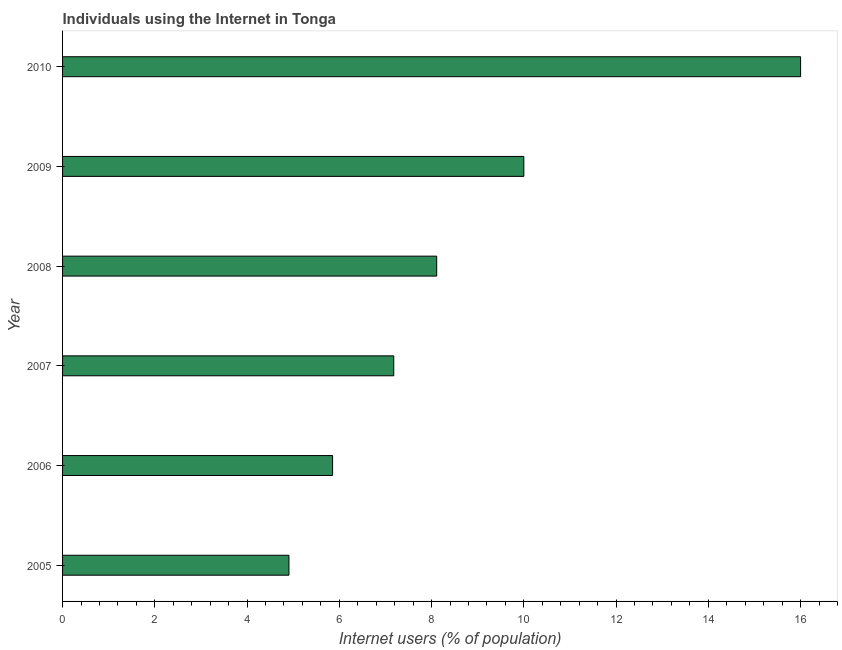Does the graph contain grids?
Offer a very short reply. No. What is the title of the graph?
Provide a succinct answer. Individuals using the Internet in Tonga. What is the label or title of the X-axis?
Make the answer very short. Internet users (% of population). What is the number of internet users in 2005?
Provide a succinct answer. 4.91. Across all years, what is the maximum number of internet users?
Ensure brevity in your answer.  16. Across all years, what is the minimum number of internet users?
Provide a succinct answer. 4.91. In which year was the number of internet users maximum?
Your response must be concise. 2010. In which year was the number of internet users minimum?
Ensure brevity in your answer.  2005. What is the sum of the number of internet users?
Give a very brief answer. 52.05. What is the difference between the number of internet users in 2005 and 2008?
Offer a very short reply. -3.2. What is the average number of internet users per year?
Make the answer very short. 8.68. What is the median number of internet users?
Make the answer very short. 7.65. What is the ratio of the number of internet users in 2007 to that in 2010?
Give a very brief answer. 0.45. Is the number of internet users in 2005 less than that in 2009?
Your answer should be compact. Yes. What is the difference between the highest and the lowest number of internet users?
Keep it short and to the point. 11.09. In how many years, is the number of internet users greater than the average number of internet users taken over all years?
Your answer should be compact. 2. What is the difference between two consecutive major ticks on the X-axis?
Provide a short and direct response. 2. Are the values on the major ticks of X-axis written in scientific E-notation?
Provide a succinct answer. No. What is the Internet users (% of population) in 2005?
Your response must be concise. 4.91. What is the Internet users (% of population) in 2006?
Offer a terse response. 5.85. What is the Internet users (% of population) in 2007?
Offer a terse response. 7.18. What is the Internet users (% of population) of 2008?
Offer a very short reply. 8.11. What is the difference between the Internet users (% of population) in 2005 and 2006?
Your answer should be very brief. -0.95. What is the difference between the Internet users (% of population) in 2005 and 2007?
Provide a succinct answer. -2.27. What is the difference between the Internet users (% of population) in 2005 and 2008?
Provide a short and direct response. -3.2. What is the difference between the Internet users (% of population) in 2005 and 2009?
Provide a short and direct response. -5.09. What is the difference between the Internet users (% of population) in 2005 and 2010?
Make the answer very short. -11.09. What is the difference between the Internet users (% of population) in 2006 and 2007?
Your answer should be compact. -1.33. What is the difference between the Internet users (% of population) in 2006 and 2008?
Ensure brevity in your answer.  -2.26. What is the difference between the Internet users (% of population) in 2006 and 2009?
Provide a succinct answer. -4.15. What is the difference between the Internet users (% of population) in 2006 and 2010?
Give a very brief answer. -10.15. What is the difference between the Internet users (% of population) in 2007 and 2008?
Provide a succinct answer. -0.93. What is the difference between the Internet users (% of population) in 2007 and 2009?
Give a very brief answer. -2.82. What is the difference between the Internet users (% of population) in 2007 and 2010?
Your answer should be compact. -8.82. What is the difference between the Internet users (% of population) in 2008 and 2009?
Your answer should be compact. -1.89. What is the difference between the Internet users (% of population) in 2008 and 2010?
Your answer should be compact. -7.89. What is the difference between the Internet users (% of population) in 2009 and 2010?
Your answer should be very brief. -6. What is the ratio of the Internet users (% of population) in 2005 to that in 2006?
Your answer should be very brief. 0.84. What is the ratio of the Internet users (% of population) in 2005 to that in 2007?
Make the answer very short. 0.68. What is the ratio of the Internet users (% of population) in 2005 to that in 2008?
Offer a very short reply. 0.6. What is the ratio of the Internet users (% of population) in 2005 to that in 2009?
Provide a short and direct response. 0.49. What is the ratio of the Internet users (% of population) in 2005 to that in 2010?
Offer a very short reply. 0.31. What is the ratio of the Internet users (% of population) in 2006 to that in 2007?
Provide a succinct answer. 0.81. What is the ratio of the Internet users (% of population) in 2006 to that in 2008?
Ensure brevity in your answer.  0.72. What is the ratio of the Internet users (% of population) in 2006 to that in 2009?
Your answer should be compact. 0.58. What is the ratio of the Internet users (% of population) in 2006 to that in 2010?
Make the answer very short. 0.37. What is the ratio of the Internet users (% of population) in 2007 to that in 2008?
Keep it short and to the point. 0.89. What is the ratio of the Internet users (% of population) in 2007 to that in 2009?
Your answer should be very brief. 0.72. What is the ratio of the Internet users (% of population) in 2007 to that in 2010?
Provide a short and direct response. 0.45. What is the ratio of the Internet users (% of population) in 2008 to that in 2009?
Offer a terse response. 0.81. What is the ratio of the Internet users (% of population) in 2008 to that in 2010?
Ensure brevity in your answer.  0.51. What is the ratio of the Internet users (% of population) in 2009 to that in 2010?
Keep it short and to the point. 0.62. 